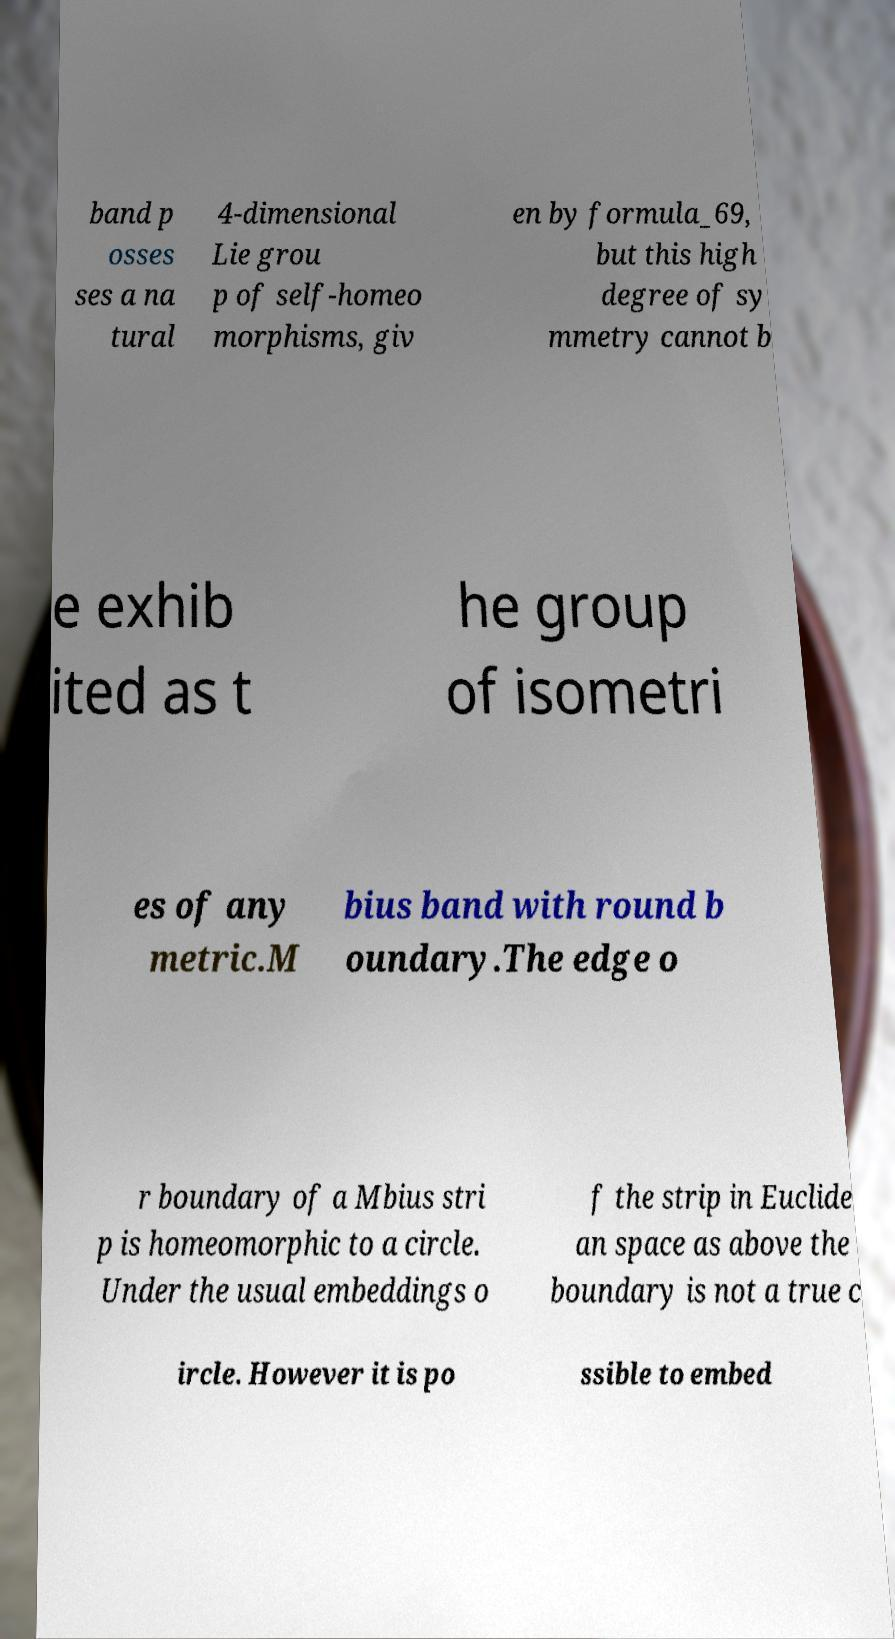Please identify and transcribe the text found in this image. band p osses ses a na tural 4-dimensional Lie grou p of self-homeo morphisms, giv en by formula_69, but this high degree of sy mmetry cannot b e exhib ited as t he group of isometri es of any metric.M bius band with round b oundary.The edge o r boundary of a Mbius stri p is homeomorphic to a circle. Under the usual embeddings o f the strip in Euclide an space as above the boundary is not a true c ircle. However it is po ssible to embed 